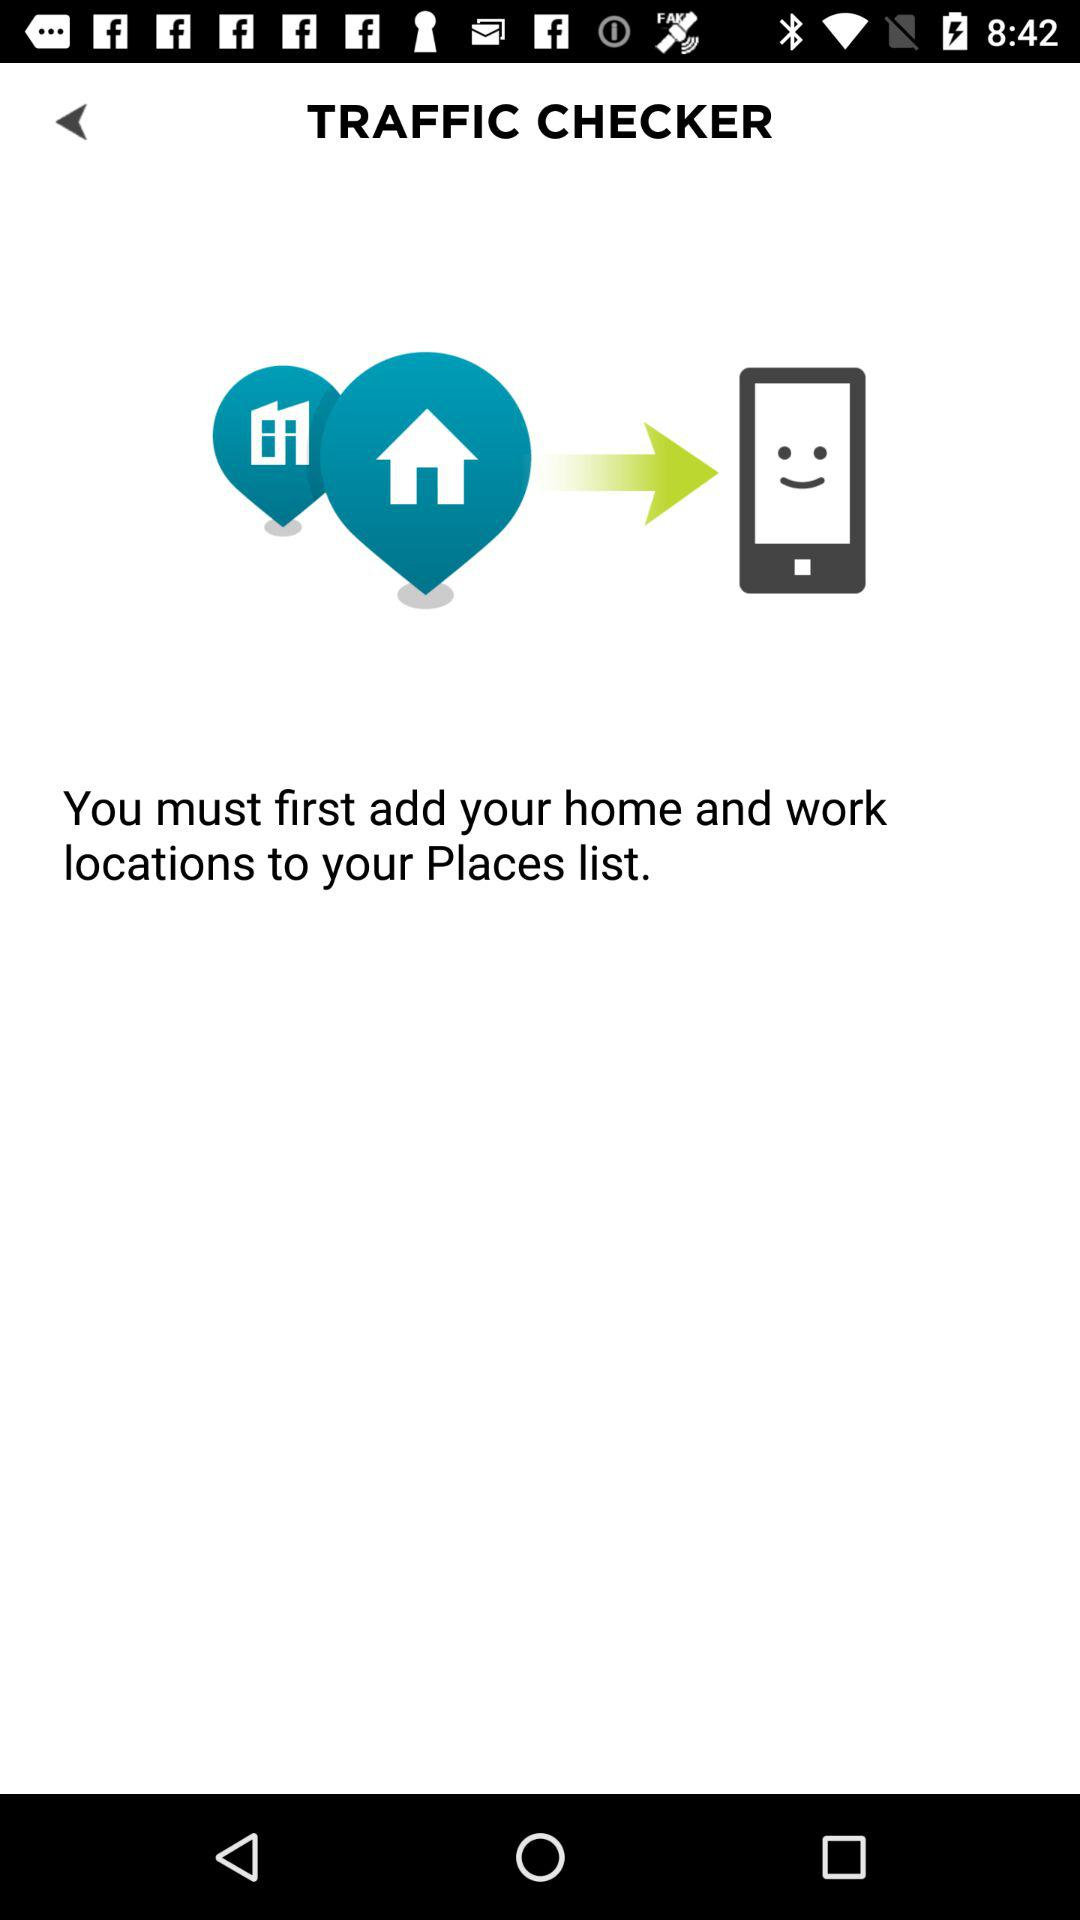What is the name of the application? The name of the application is "TRAFFIC CHECKER". 